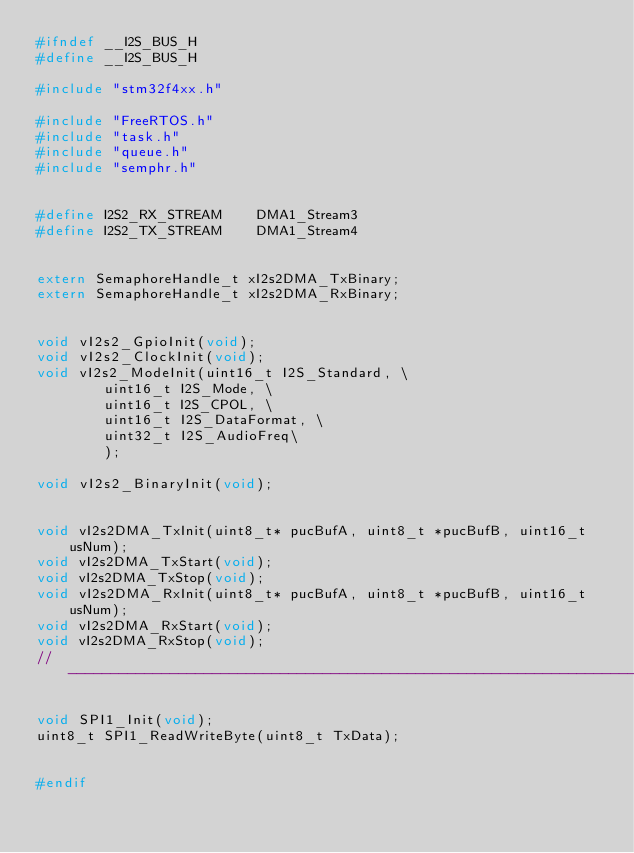Convert code to text. <code><loc_0><loc_0><loc_500><loc_500><_C_>#ifndef __I2S_BUS_H
#define __I2S_BUS_H

#include "stm32f4xx.h"

#include "FreeRTOS.h"
#include "task.h"
#include "queue.h"
#include "semphr.h"


#define I2S2_RX_STREAM		DMA1_Stream3
#define I2S2_TX_STREAM		DMA1_Stream4


extern SemaphoreHandle_t xI2s2DMA_TxBinary;
extern SemaphoreHandle_t xI2s2DMA_RxBinary;


void vI2s2_GpioInit(void);
void vI2s2_ClockInit(void);
void vI2s2_ModeInit(uint16_t I2S_Standard, \
				uint16_t I2S_Mode, \
				uint16_t I2S_CPOL, \
				uint16_t I2S_DataFormat, \
				uint32_t I2S_AudioFreq\
				);

void vI2s2_BinaryInit(void);


void vI2s2DMA_TxInit(uint8_t* pucBufA, uint8_t *pucBufB, uint16_t usNum);
void vI2s2DMA_TxStart(void);
void vI2s2DMA_TxStop(void);
void vI2s2DMA_RxInit(uint8_t* pucBufA, uint8_t *pucBufB, uint16_t usNum);
void vI2s2DMA_RxStart(void);
void vI2s2DMA_RxStop(void);
//----------------------------------------------------------------------------------------

void SPI1_Init(void);
uint8_t SPI1_ReadWriteByte(uint8_t TxData);


#endif

</code> 